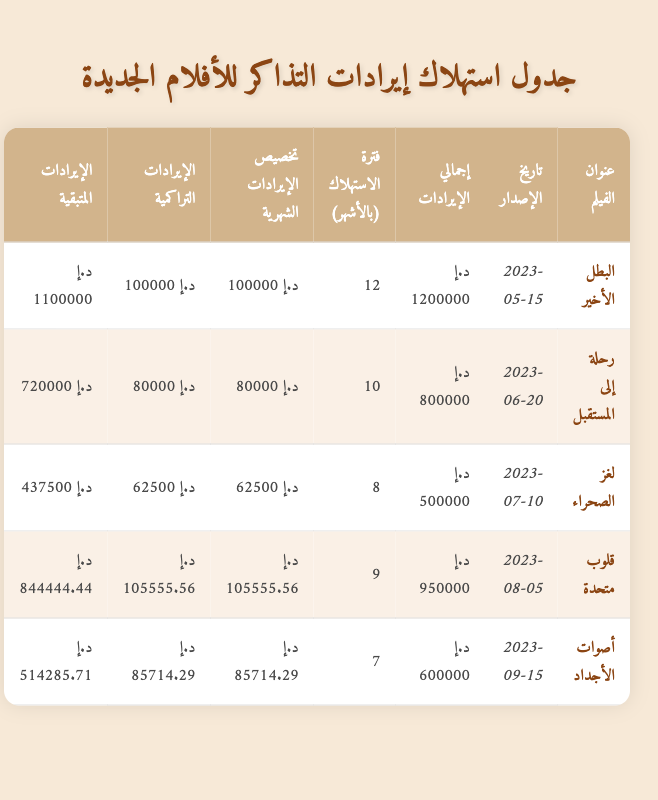What is the total revenue of the movie "The Last Hero"? From the table, the total revenue for "The Last Hero" is listed in the respective row under the column "إجمالي الإيرادات". The value is 1,200,000.
Answer: 1,200,000 What is the remaining revenue for "Voices of the Ancients"? The remaining revenue for "Voices of the Ancients" can be found in the table under the column "الإيرادات المتبقية". The value provided is 514,285.71.
Answer: 514,285.71 How many months is the amortization period for "Journey to the Future"? Looking at the table under the column "فترة الاستهلاك (بالأشهر)", the amortization period for "Journey to the Future" is 10 months.
Answer: 10 months Which movie has the highest total revenue? To find this, we compare the total revenue values from the "إجمالي الإيرادات" column across all movies. The highest value is 1,200,000, which belongs to "The Last Hero".
Answer: The Last Hero What is the cumulative revenue for "Hearts United"? The cumulative revenue for "Hearts United" is reported under the "الإيرادات التراكمية" column. The value is 105,555.56.
Answer: 105,555.56 Is the monthly revenue allocation for "Mystery of the Desert" greater than 60,000? Looking at the "تخصيص الإيرادات الشهرية" column, the monthly revenue allocation for "Mystery of the Desert" is 62,500, which is greater than 60,000.
Answer: Yes What is the average monthly revenue allocation for all movies listed in the table? First, we sum the monthly revenue allocations: 100,000 + 80,000 + 62,500 + 105,555.56 + 85,714.29 = 433,769.85. There are 5 movies, so dividing this total by 5 gives us an average of 86,753.97.
Answer: 86,753.97 What is the total remaining revenue for all the movies combined? We sum the remaining revenue from all rows: 1,100,000 + 720,000 + 437,500 + 844,444.44 + 514,285.71 = 2,616,230.15. Thus, the total remaining revenue is 2,616,230.15.
Answer: 2,616,230.15 For how many movies does the amortization period exceed 8 months? By checking the "فترة الاستهلاك (بالأشهر)" column, "The Last Hero" (12), "Journey to the Future" (10), "Hearts United" (9), and "Voices of the Ancients" (7) — only 4 movies exceed 8 months.
Answer: 4 movies 